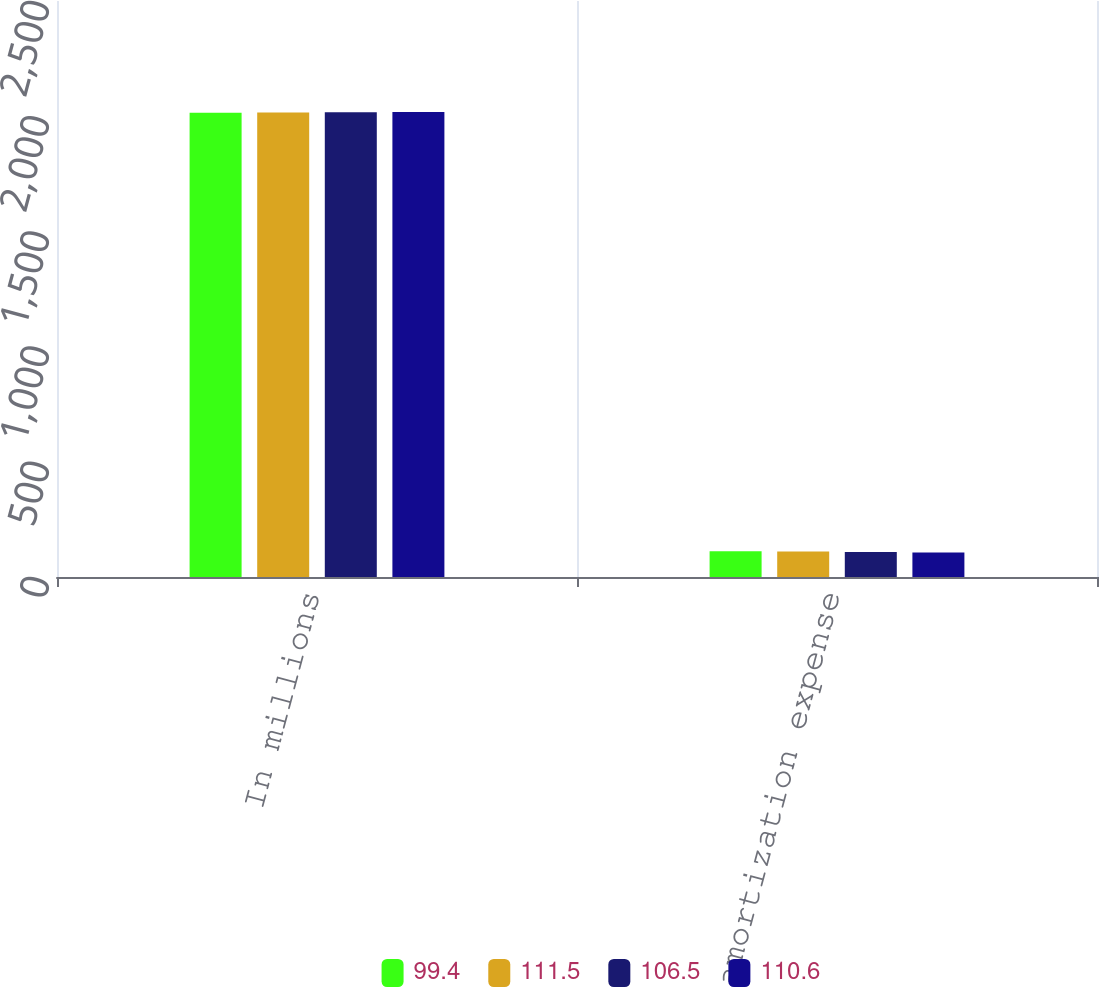<chart> <loc_0><loc_0><loc_500><loc_500><stacked_bar_chart><ecel><fcel>In millions<fcel>Estimated amortization expense<nl><fcel>99.4<fcel>2015<fcel>111.5<nl><fcel>111.5<fcel>2016<fcel>110.6<nl><fcel>106.5<fcel>2017<fcel>109<nl><fcel>110.6<fcel>2018<fcel>106.5<nl></chart> 